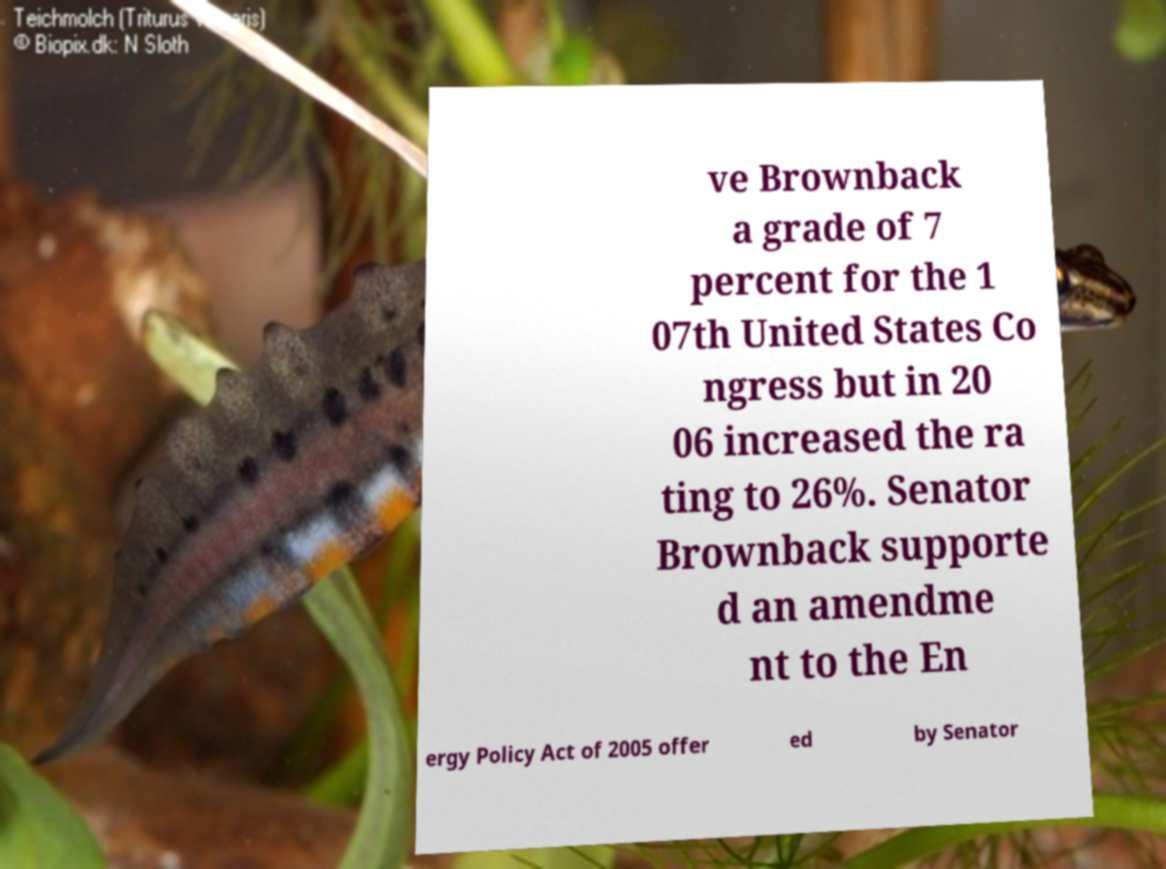Please read and relay the text visible in this image. What does it say? ve Brownback a grade of 7 percent for the 1 07th United States Co ngress but in 20 06 increased the ra ting to 26%. Senator Brownback supporte d an amendme nt to the En ergy Policy Act of 2005 offer ed by Senator 